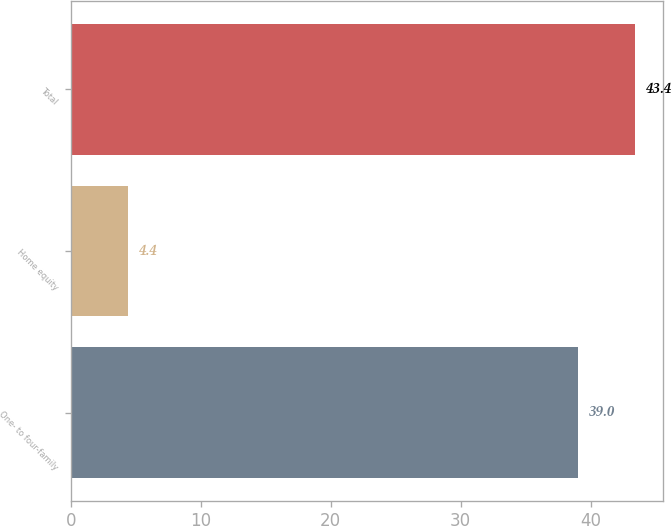Convert chart. <chart><loc_0><loc_0><loc_500><loc_500><bar_chart><fcel>One- to four-family<fcel>Home equity<fcel>Total<nl><fcel>39<fcel>4.4<fcel>43.4<nl></chart> 